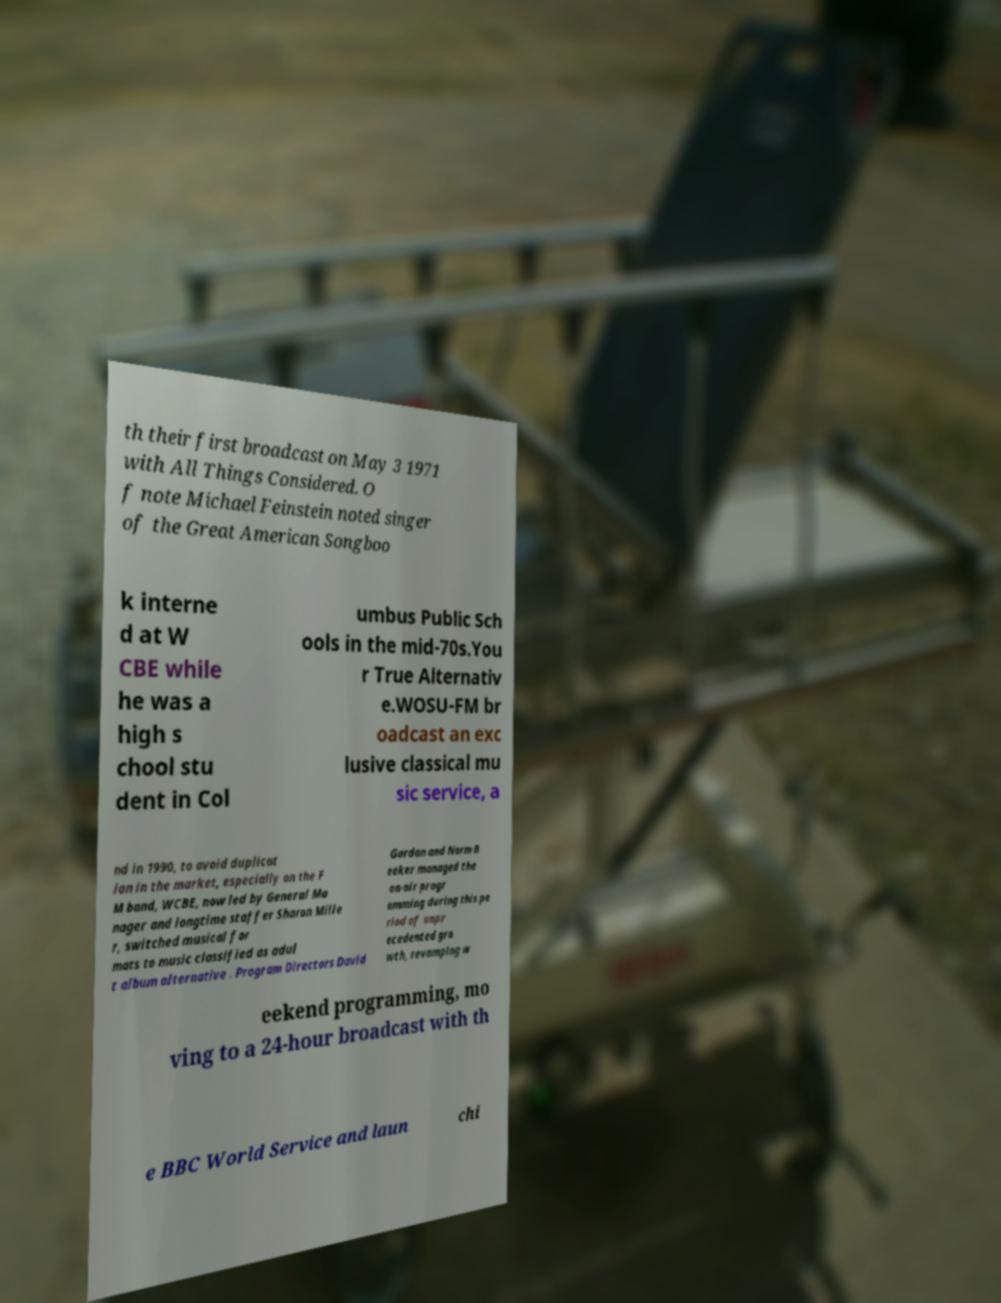Can you accurately transcribe the text from the provided image for me? th their first broadcast on May 3 1971 with All Things Considered. O f note Michael Feinstein noted singer of the Great American Songboo k interne d at W CBE while he was a high s chool stu dent in Col umbus Public Sch ools in the mid-70s.You r True Alternativ e.WOSU-FM br oadcast an exc lusive classical mu sic service, a nd in 1990, to avoid duplicat ion in the market, especially on the F M band, WCBE, now led by General Ma nager and longtime staffer Sharon Mille r, switched musical for mats to music classified as adul t album alternative . Program Directors David Gordon and Norm B eeker managed the on-air progr amming during this pe riod of unpr ecedented gro wth, revamping w eekend programming, mo ving to a 24-hour broadcast with th e BBC World Service and laun chi 